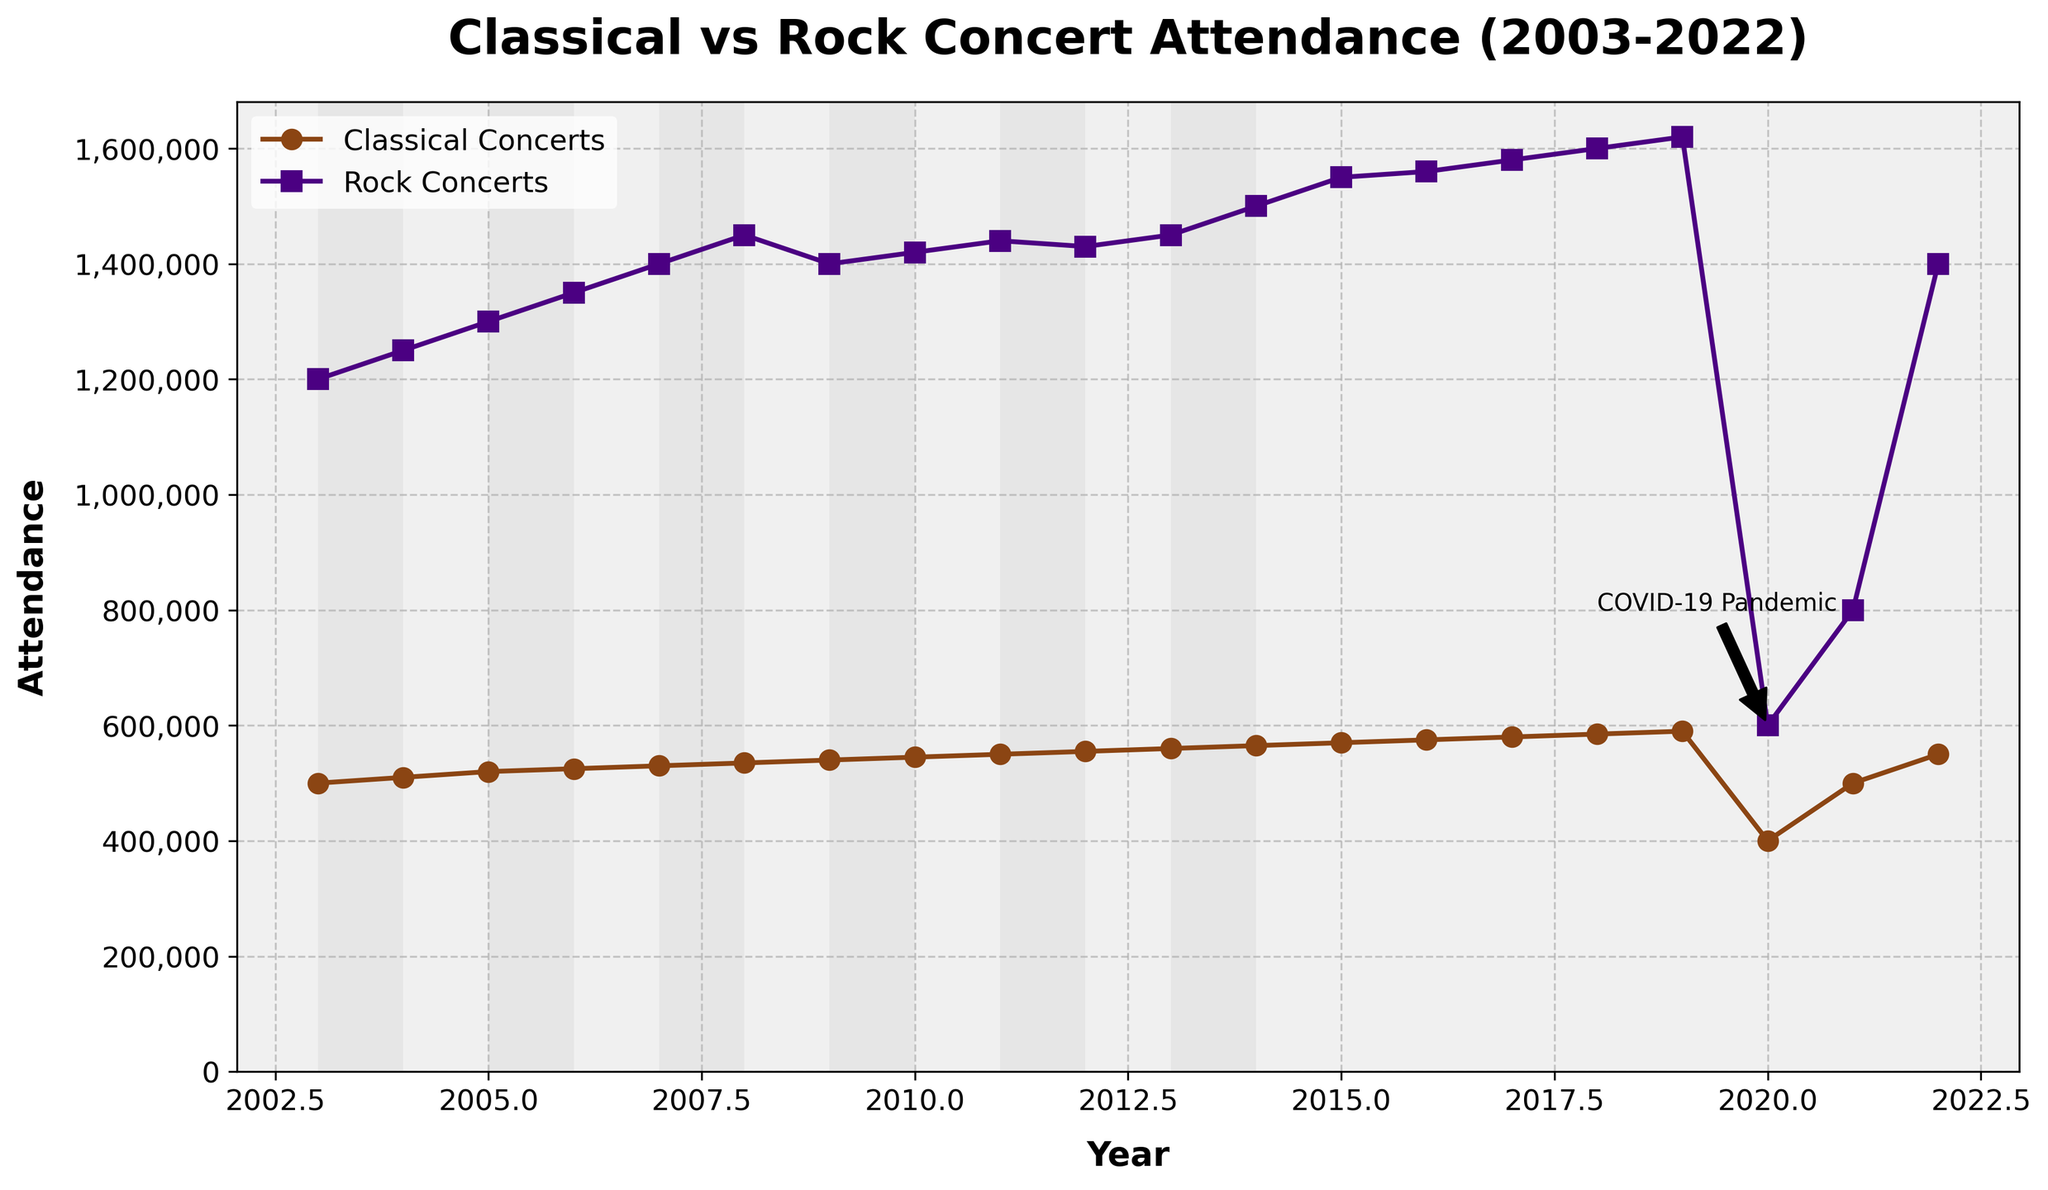What is the title of the plot? The title of the plot is located at the top center of the figure, written in a larger, bold font.
Answer: Classical vs Rock Concert Attendance (2003-2022) What is the attendance for classical concerts in 2020? Find the year 2020 on the x-axis, then look at the corresponding y-value on the classical concert attendance line (brown line with circular markers).
Answer: 400000 Which concert type had the higher attendance in 2003? Compare the y-values for both classical and rock concerts at the year 2003. The rock concert line (purple line with square markers) is higher.
Answer: Rock concerts In which year did rock concert attendance peak? Identify the highest point on the purple line (rock concerts) and note the corresponding year on the x-axis.
Answer: 2019 What significant event is annotated on the plot? There is an annotation with a text label and an arrow pointing to the year 2020, explaining the drop during that period.
Answer: COVID-19 Pandemic Calculate the average attendance for classical concerts from 2003 to 2007. Add the attendance numbers from 2003 to 2007 and divide by the number of years: (500000 + 510000 + 520000 + 525000 + 530000) / 5 = 2585000 / 5.
Answer: 517000 What was the trend in rock concert attendance from 2010 to 2014? Follow the rock concert line from 2010 to 2014. The attendance increases each year during this period.
Answer: Increasing Which year shows a recovery in attendance for both types of concerts after the drop in 2020? Look for the year after 2020 where both attendance lines show an increase, which is 2021.
Answer: 2021 By how much did the classical concert attendance change from 2019 to 2020? Subtract the 2020 attendance from the 2019 attendance for classical concerts: 590000 - 400000.
Answer: 190000 How does the background of the plot reflect a subtle piano keyboard pattern? The background contains alternating rectangular patches, representing the keys of a piano, with a light grey and white color scheme.
Answer: Rectangular patches 